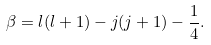Convert formula to latex. <formula><loc_0><loc_0><loc_500><loc_500>\beta = l ( l + 1 ) - j ( j + 1 ) - \frac { 1 } { 4 } .</formula> 